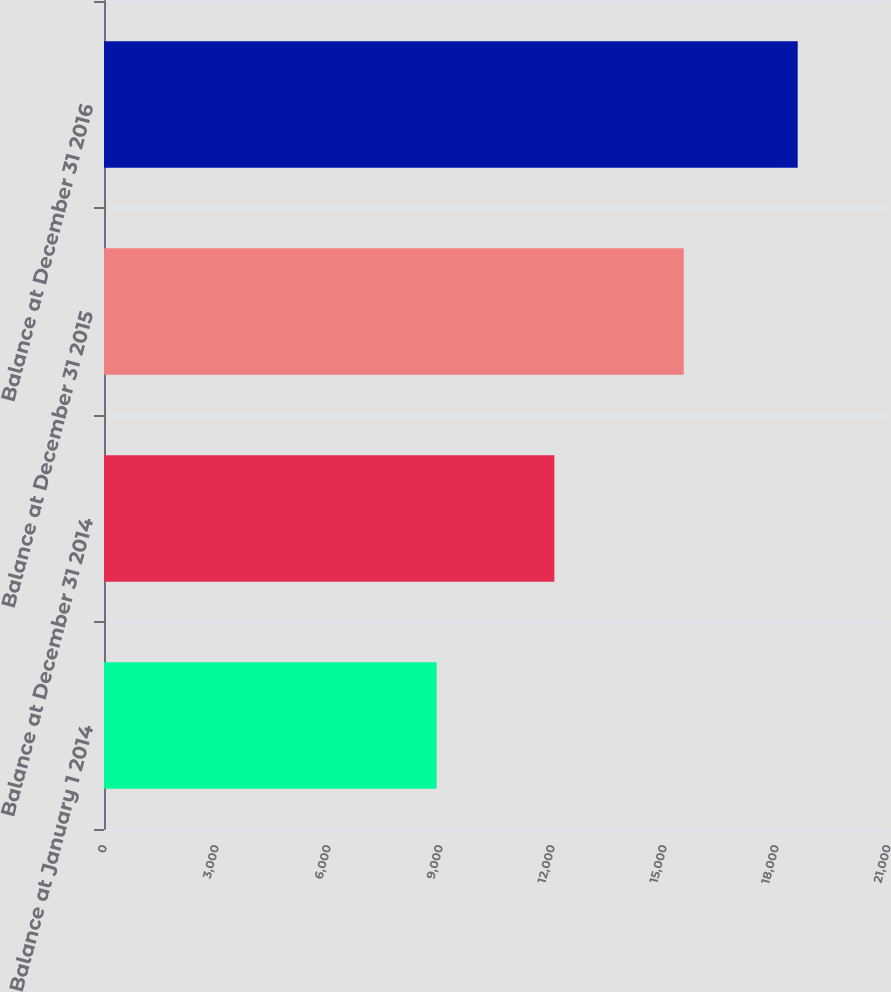Convert chart. <chart><loc_0><loc_0><loc_500><loc_500><bar_chart><fcel>Balance at January 1 2014<fcel>Balance at December 31 2014<fcel>Balance at December 31 2015<fcel>Balance at December 31 2016<nl><fcel>8910<fcel>12064<fcel>15529<fcel>18581<nl></chart> 